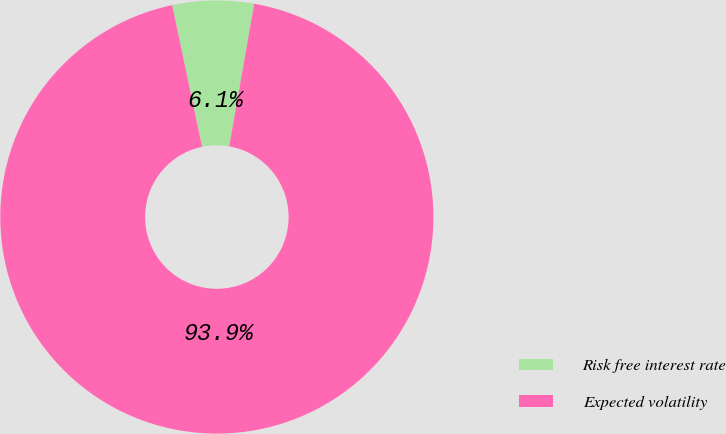<chart> <loc_0><loc_0><loc_500><loc_500><pie_chart><fcel>Risk free interest rate<fcel>Expected volatility<nl><fcel>6.07%<fcel>93.93%<nl></chart> 